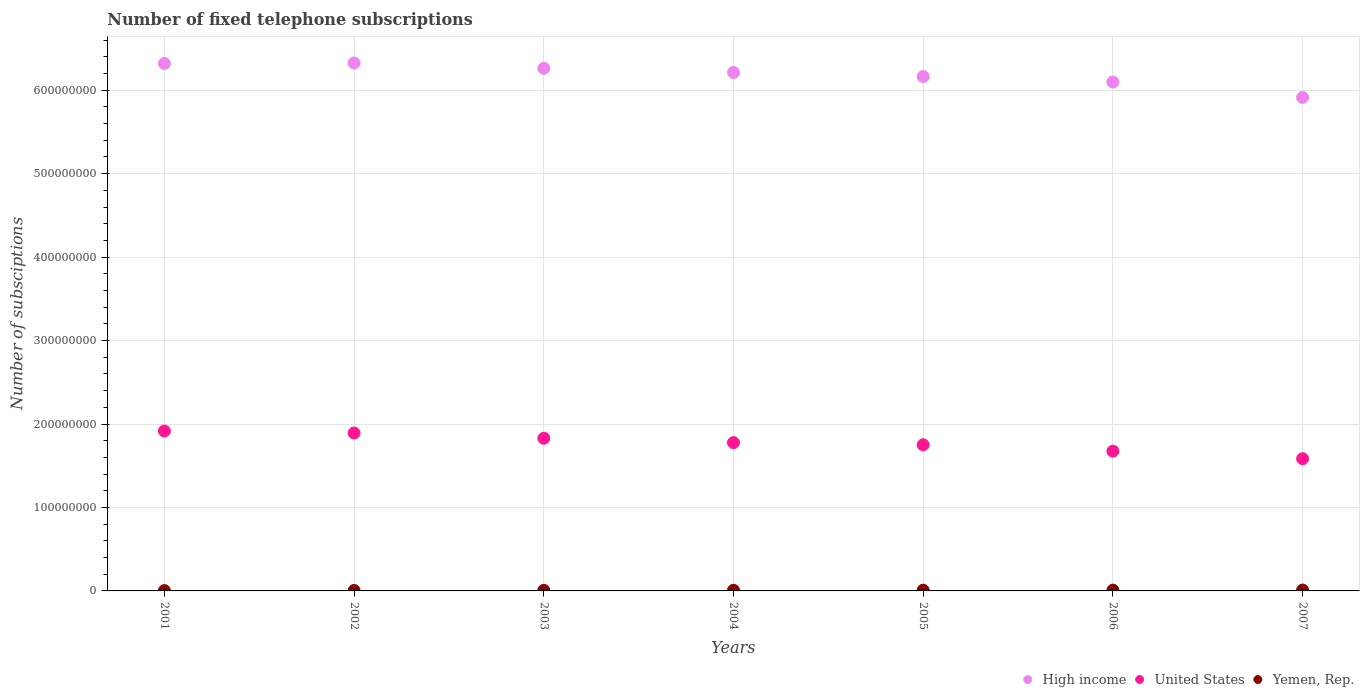How many different coloured dotlines are there?
Keep it short and to the point. 3. Is the number of dotlines equal to the number of legend labels?
Make the answer very short. Yes. What is the number of fixed telephone subscriptions in United States in 2006?
Provide a succinct answer. 1.67e+08. Across all years, what is the maximum number of fixed telephone subscriptions in United States?
Make the answer very short. 1.92e+08. Across all years, what is the minimum number of fixed telephone subscriptions in United States?
Offer a terse response. 1.58e+08. In which year was the number of fixed telephone subscriptions in High income minimum?
Provide a succinct answer. 2007. What is the total number of fixed telephone subscriptions in High income in the graph?
Keep it short and to the point. 4.33e+09. What is the difference between the number of fixed telephone subscriptions in United States in 2004 and that in 2007?
Your answer should be compact. 1.93e+07. What is the difference between the number of fixed telephone subscriptions in High income in 2006 and the number of fixed telephone subscriptions in United States in 2003?
Offer a very short reply. 4.27e+08. What is the average number of fixed telephone subscriptions in High income per year?
Your response must be concise. 6.19e+08. In the year 2004, what is the difference between the number of fixed telephone subscriptions in Yemen, Rep. and number of fixed telephone subscriptions in High income?
Your answer should be compact. -6.20e+08. What is the ratio of the number of fixed telephone subscriptions in Yemen, Rep. in 2005 to that in 2006?
Keep it short and to the point. 0.93. Is the number of fixed telephone subscriptions in Yemen, Rep. in 2002 less than that in 2003?
Give a very brief answer. Yes. What is the difference between the highest and the second highest number of fixed telephone subscriptions in United States?
Your answer should be very brief. 2.32e+06. What is the difference between the highest and the lowest number of fixed telephone subscriptions in High income?
Provide a succinct answer. 4.13e+07. In how many years, is the number of fixed telephone subscriptions in High income greater than the average number of fixed telephone subscriptions in High income taken over all years?
Make the answer very short. 4. Is the number of fixed telephone subscriptions in Yemen, Rep. strictly greater than the number of fixed telephone subscriptions in High income over the years?
Your answer should be compact. No. How many dotlines are there?
Provide a succinct answer. 3. How many years are there in the graph?
Give a very brief answer. 7. What is the difference between two consecutive major ticks on the Y-axis?
Ensure brevity in your answer.  1.00e+08. Does the graph contain grids?
Your response must be concise. Yes. How many legend labels are there?
Give a very brief answer. 3. What is the title of the graph?
Offer a terse response. Number of fixed telephone subscriptions. What is the label or title of the X-axis?
Your answer should be very brief. Years. What is the label or title of the Y-axis?
Your answer should be compact. Number of subsciptions. What is the Number of subsciptions of High income in 2001?
Offer a terse response. 6.32e+08. What is the Number of subsciptions of United States in 2001?
Provide a short and direct response. 1.92e+08. What is the Number of subsciptions of Yemen, Rep. in 2001?
Provide a short and direct response. 4.22e+05. What is the Number of subsciptions of High income in 2002?
Provide a succinct answer. 6.33e+08. What is the Number of subsciptions of United States in 2002?
Make the answer very short. 1.89e+08. What is the Number of subsciptions of Yemen, Rep. in 2002?
Give a very brief answer. 5.42e+05. What is the Number of subsciptions of High income in 2003?
Ensure brevity in your answer.  6.26e+08. What is the Number of subsciptions of United States in 2003?
Your answer should be compact. 1.83e+08. What is the Number of subsciptions of Yemen, Rep. in 2003?
Provide a short and direct response. 6.94e+05. What is the Number of subsciptions of High income in 2004?
Your response must be concise. 6.21e+08. What is the Number of subsciptions in United States in 2004?
Offer a terse response. 1.78e+08. What is the Number of subsciptions in Yemen, Rep. in 2004?
Your answer should be compact. 7.98e+05. What is the Number of subsciptions of High income in 2005?
Your answer should be very brief. 6.16e+08. What is the Number of subsciptions in United States in 2005?
Offer a terse response. 1.75e+08. What is the Number of subsciptions of Yemen, Rep. in 2005?
Your response must be concise. 9.01e+05. What is the Number of subsciptions in High income in 2006?
Ensure brevity in your answer.  6.10e+08. What is the Number of subsciptions in United States in 2006?
Offer a very short reply. 1.67e+08. What is the Number of subsciptions in Yemen, Rep. in 2006?
Your answer should be compact. 9.68e+05. What is the Number of subsciptions of High income in 2007?
Give a very brief answer. 5.91e+08. What is the Number of subsciptions in United States in 2007?
Offer a terse response. 1.58e+08. What is the Number of subsciptions in Yemen, Rep. in 2007?
Provide a succinct answer. 1.02e+06. Across all years, what is the maximum Number of subsciptions of High income?
Give a very brief answer. 6.33e+08. Across all years, what is the maximum Number of subsciptions in United States?
Your answer should be compact. 1.92e+08. Across all years, what is the maximum Number of subsciptions in Yemen, Rep.?
Your response must be concise. 1.02e+06. Across all years, what is the minimum Number of subsciptions in High income?
Make the answer very short. 5.91e+08. Across all years, what is the minimum Number of subsciptions of United States?
Offer a terse response. 1.58e+08. Across all years, what is the minimum Number of subsciptions of Yemen, Rep.?
Provide a short and direct response. 4.22e+05. What is the total Number of subsciptions of High income in the graph?
Your answer should be very brief. 4.33e+09. What is the total Number of subsciptions of United States in the graph?
Your answer should be compact. 1.24e+09. What is the total Number of subsciptions in Yemen, Rep. in the graph?
Make the answer very short. 5.35e+06. What is the difference between the Number of subsciptions of High income in 2001 and that in 2002?
Keep it short and to the point. -6.04e+05. What is the difference between the Number of subsciptions in United States in 2001 and that in 2002?
Your answer should be compact. 2.32e+06. What is the difference between the Number of subsciptions in Yemen, Rep. in 2001 and that in 2002?
Your answer should be compact. -1.20e+05. What is the difference between the Number of subsciptions in High income in 2001 and that in 2003?
Offer a very short reply. 5.84e+06. What is the difference between the Number of subsciptions of United States in 2001 and that in 2003?
Ensure brevity in your answer.  8.64e+06. What is the difference between the Number of subsciptions in Yemen, Rep. in 2001 and that in 2003?
Provide a succinct answer. -2.72e+05. What is the difference between the Number of subsciptions of High income in 2001 and that in 2004?
Make the answer very short. 1.08e+07. What is the difference between the Number of subsciptions of United States in 2001 and that in 2004?
Provide a succinct answer. 1.39e+07. What is the difference between the Number of subsciptions of Yemen, Rep. in 2001 and that in 2004?
Your response must be concise. -3.76e+05. What is the difference between the Number of subsciptions of High income in 2001 and that in 2005?
Make the answer very short. 1.56e+07. What is the difference between the Number of subsciptions of United States in 2001 and that in 2005?
Your answer should be very brief. 1.64e+07. What is the difference between the Number of subsciptions of Yemen, Rep. in 2001 and that in 2005?
Provide a short and direct response. -4.79e+05. What is the difference between the Number of subsciptions of High income in 2001 and that in 2006?
Provide a succinct answer. 2.22e+07. What is the difference between the Number of subsciptions of United States in 2001 and that in 2006?
Offer a very short reply. 2.41e+07. What is the difference between the Number of subsciptions in Yemen, Rep. in 2001 and that in 2006?
Provide a short and direct response. -5.46e+05. What is the difference between the Number of subsciptions of High income in 2001 and that in 2007?
Offer a terse response. 4.07e+07. What is the difference between the Number of subsciptions in United States in 2001 and that in 2007?
Your response must be concise. 3.32e+07. What is the difference between the Number of subsciptions in Yemen, Rep. in 2001 and that in 2007?
Offer a terse response. -6.00e+05. What is the difference between the Number of subsciptions in High income in 2002 and that in 2003?
Provide a succinct answer. 6.45e+06. What is the difference between the Number of subsciptions in United States in 2002 and that in 2003?
Offer a very short reply. 6.32e+06. What is the difference between the Number of subsciptions of Yemen, Rep. in 2002 and that in 2003?
Keep it short and to the point. -1.52e+05. What is the difference between the Number of subsciptions of High income in 2002 and that in 2004?
Offer a terse response. 1.14e+07. What is the difference between the Number of subsciptions in United States in 2002 and that in 2004?
Your answer should be very brief. 1.16e+07. What is the difference between the Number of subsciptions in Yemen, Rep. in 2002 and that in 2004?
Offer a very short reply. -2.56e+05. What is the difference between the Number of subsciptions in High income in 2002 and that in 2005?
Your response must be concise. 1.63e+07. What is the difference between the Number of subsciptions in United States in 2002 and that in 2005?
Your answer should be very brief. 1.41e+07. What is the difference between the Number of subsciptions of Yemen, Rep. in 2002 and that in 2005?
Offer a terse response. -3.59e+05. What is the difference between the Number of subsciptions of High income in 2002 and that in 2006?
Make the answer very short. 2.28e+07. What is the difference between the Number of subsciptions of United States in 2002 and that in 2006?
Offer a terse response. 2.18e+07. What is the difference between the Number of subsciptions in Yemen, Rep. in 2002 and that in 2006?
Your answer should be compact. -4.26e+05. What is the difference between the Number of subsciptions in High income in 2002 and that in 2007?
Your answer should be very brief. 4.13e+07. What is the difference between the Number of subsciptions in United States in 2002 and that in 2007?
Provide a succinct answer. 3.08e+07. What is the difference between the Number of subsciptions in Yemen, Rep. in 2002 and that in 2007?
Your answer should be compact. -4.80e+05. What is the difference between the Number of subsciptions in High income in 2003 and that in 2004?
Your answer should be compact. 4.92e+06. What is the difference between the Number of subsciptions in United States in 2003 and that in 2004?
Provide a short and direct response. 5.24e+06. What is the difference between the Number of subsciptions in Yemen, Rep. in 2003 and that in 2004?
Your response must be concise. -1.04e+05. What is the difference between the Number of subsciptions of High income in 2003 and that in 2005?
Offer a terse response. 9.80e+06. What is the difference between the Number of subsciptions in United States in 2003 and that in 2005?
Provide a succinct answer. 7.77e+06. What is the difference between the Number of subsciptions of Yemen, Rep. in 2003 and that in 2005?
Provide a succinct answer. -2.08e+05. What is the difference between the Number of subsciptions in High income in 2003 and that in 2006?
Offer a terse response. 1.64e+07. What is the difference between the Number of subsciptions in United States in 2003 and that in 2006?
Give a very brief answer. 1.55e+07. What is the difference between the Number of subsciptions of Yemen, Rep. in 2003 and that in 2006?
Offer a very short reply. -2.74e+05. What is the difference between the Number of subsciptions of High income in 2003 and that in 2007?
Your answer should be compact. 3.49e+07. What is the difference between the Number of subsciptions in United States in 2003 and that in 2007?
Make the answer very short. 2.45e+07. What is the difference between the Number of subsciptions in Yemen, Rep. in 2003 and that in 2007?
Provide a succinct answer. -3.28e+05. What is the difference between the Number of subsciptions of High income in 2004 and that in 2005?
Your answer should be very brief. 4.88e+06. What is the difference between the Number of subsciptions in United States in 2004 and that in 2005?
Your response must be concise. 2.53e+06. What is the difference between the Number of subsciptions of Yemen, Rep. in 2004 and that in 2005?
Offer a very short reply. -1.03e+05. What is the difference between the Number of subsciptions in High income in 2004 and that in 2006?
Provide a short and direct response. 1.14e+07. What is the difference between the Number of subsciptions of United States in 2004 and that in 2006?
Offer a very short reply. 1.02e+07. What is the difference between the Number of subsciptions in Yemen, Rep. in 2004 and that in 2006?
Offer a very short reply. -1.70e+05. What is the difference between the Number of subsciptions of High income in 2004 and that in 2007?
Ensure brevity in your answer.  2.99e+07. What is the difference between the Number of subsciptions of United States in 2004 and that in 2007?
Your response must be concise. 1.93e+07. What is the difference between the Number of subsciptions in Yemen, Rep. in 2004 and that in 2007?
Provide a short and direct response. -2.24e+05. What is the difference between the Number of subsciptions of High income in 2005 and that in 2006?
Your answer should be very brief. 6.56e+06. What is the difference between the Number of subsciptions in United States in 2005 and that in 2006?
Offer a terse response. 7.70e+06. What is the difference between the Number of subsciptions in Yemen, Rep. in 2005 and that in 2006?
Offer a very short reply. -6.69e+04. What is the difference between the Number of subsciptions in High income in 2005 and that in 2007?
Offer a very short reply. 2.50e+07. What is the difference between the Number of subsciptions in United States in 2005 and that in 2007?
Make the answer very short. 1.67e+07. What is the difference between the Number of subsciptions in Yemen, Rep. in 2005 and that in 2007?
Give a very brief answer. -1.21e+05. What is the difference between the Number of subsciptions in High income in 2006 and that in 2007?
Make the answer very short. 1.85e+07. What is the difference between the Number of subsciptions in United States in 2006 and that in 2007?
Provide a succinct answer. 9.04e+06. What is the difference between the Number of subsciptions of Yemen, Rep. in 2006 and that in 2007?
Keep it short and to the point. -5.37e+04. What is the difference between the Number of subsciptions of High income in 2001 and the Number of subsciptions of United States in 2002?
Offer a terse response. 4.43e+08. What is the difference between the Number of subsciptions of High income in 2001 and the Number of subsciptions of Yemen, Rep. in 2002?
Your answer should be compact. 6.31e+08. What is the difference between the Number of subsciptions in United States in 2001 and the Number of subsciptions in Yemen, Rep. in 2002?
Give a very brief answer. 1.91e+08. What is the difference between the Number of subsciptions in High income in 2001 and the Number of subsciptions in United States in 2003?
Give a very brief answer. 4.49e+08. What is the difference between the Number of subsciptions of High income in 2001 and the Number of subsciptions of Yemen, Rep. in 2003?
Provide a succinct answer. 6.31e+08. What is the difference between the Number of subsciptions in United States in 2001 and the Number of subsciptions in Yemen, Rep. in 2003?
Provide a succinct answer. 1.91e+08. What is the difference between the Number of subsciptions of High income in 2001 and the Number of subsciptions of United States in 2004?
Your response must be concise. 4.54e+08. What is the difference between the Number of subsciptions in High income in 2001 and the Number of subsciptions in Yemen, Rep. in 2004?
Keep it short and to the point. 6.31e+08. What is the difference between the Number of subsciptions in United States in 2001 and the Number of subsciptions in Yemen, Rep. in 2004?
Ensure brevity in your answer.  1.91e+08. What is the difference between the Number of subsciptions in High income in 2001 and the Number of subsciptions in United States in 2005?
Offer a terse response. 4.57e+08. What is the difference between the Number of subsciptions of High income in 2001 and the Number of subsciptions of Yemen, Rep. in 2005?
Your response must be concise. 6.31e+08. What is the difference between the Number of subsciptions in United States in 2001 and the Number of subsciptions in Yemen, Rep. in 2005?
Offer a terse response. 1.91e+08. What is the difference between the Number of subsciptions of High income in 2001 and the Number of subsciptions of United States in 2006?
Offer a terse response. 4.65e+08. What is the difference between the Number of subsciptions of High income in 2001 and the Number of subsciptions of Yemen, Rep. in 2006?
Keep it short and to the point. 6.31e+08. What is the difference between the Number of subsciptions in United States in 2001 and the Number of subsciptions in Yemen, Rep. in 2006?
Provide a short and direct response. 1.91e+08. What is the difference between the Number of subsciptions in High income in 2001 and the Number of subsciptions in United States in 2007?
Ensure brevity in your answer.  4.74e+08. What is the difference between the Number of subsciptions in High income in 2001 and the Number of subsciptions in Yemen, Rep. in 2007?
Make the answer very short. 6.31e+08. What is the difference between the Number of subsciptions of United States in 2001 and the Number of subsciptions of Yemen, Rep. in 2007?
Offer a very short reply. 1.91e+08. What is the difference between the Number of subsciptions in High income in 2002 and the Number of subsciptions in United States in 2003?
Offer a terse response. 4.50e+08. What is the difference between the Number of subsciptions of High income in 2002 and the Number of subsciptions of Yemen, Rep. in 2003?
Keep it short and to the point. 6.32e+08. What is the difference between the Number of subsciptions of United States in 2002 and the Number of subsciptions of Yemen, Rep. in 2003?
Your response must be concise. 1.89e+08. What is the difference between the Number of subsciptions of High income in 2002 and the Number of subsciptions of United States in 2004?
Give a very brief answer. 4.55e+08. What is the difference between the Number of subsciptions of High income in 2002 and the Number of subsciptions of Yemen, Rep. in 2004?
Your response must be concise. 6.32e+08. What is the difference between the Number of subsciptions of United States in 2002 and the Number of subsciptions of Yemen, Rep. in 2004?
Offer a very short reply. 1.88e+08. What is the difference between the Number of subsciptions in High income in 2002 and the Number of subsciptions in United States in 2005?
Make the answer very short. 4.57e+08. What is the difference between the Number of subsciptions in High income in 2002 and the Number of subsciptions in Yemen, Rep. in 2005?
Give a very brief answer. 6.32e+08. What is the difference between the Number of subsciptions of United States in 2002 and the Number of subsciptions of Yemen, Rep. in 2005?
Your response must be concise. 1.88e+08. What is the difference between the Number of subsciptions of High income in 2002 and the Number of subsciptions of United States in 2006?
Offer a terse response. 4.65e+08. What is the difference between the Number of subsciptions in High income in 2002 and the Number of subsciptions in Yemen, Rep. in 2006?
Give a very brief answer. 6.32e+08. What is the difference between the Number of subsciptions in United States in 2002 and the Number of subsciptions in Yemen, Rep. in 2006?
Your answer should be compact. 1.88e+08. What is the difference between the Number of subsciptions in High income in 2002 and the Number of subsciptions in United States in 2007?
Your answer should be very brief. 4.74e+08. What is the difference between the Number of subsciptions of High income in 2002 and the Number of subsciptions of Yemen, Rep. in 2007?
Your answer should be compact. 6.32e+08. What is the difference between the Number of subsciptions of United States in 2002 and the Number of subsciptions of Yemen, Rep. in 2007?
Your answer should be compact. 1.88e+08. What is the difference between the Number of subsciptions of High income in 2003 and the Number of subsciptions of United States in 2004?
Offer a terse response. 4.48e+08. What is the difference between the Number of subsciptions of High income in 2003 and the Number of subsciptions of Yemen, Rep. in 2004?
Your answer should be very brief. 6.25e+08. What is the difference between the Number of subsciptions in United States in 2003 and the Number of subsciptions in Yemen, Rep. in 2004?
Your response must be concise. 1.82e+08. What is the difference between the Number of subsciptions in High income in 2003 and the Number of subsciptions in United States in 2005?
Make the answer very short. 4.51e+08. What is the difference between the Number of subsciptions in High income in 2003 and the Number of subsciptions in Yemen, Rep. in 2005?
Your answer should be very brief. 6.25e+08. What is the difference between the Number of subsciptions in United States in 2003 and the Number of subsciptions in Yemen, Rep. in 2005?
Provide a succinct answer. 1.82e+08. What is the difference between the Number of subsciptions of High income in 2003 and the Number of subsciptions of United States in 2006?
Your answer should be compact. 4.59e+08. What is the difference between the Number of subsciptions of High income in 2003 and the Number of subsciptions of Yemen, Rep. in 2006?
Keep it short and to the point. 6.25e+08. What is the difference between the Number of subsciptions in United States in 2003 and the Number of subsciptions in Yemen, Rep. in 2006?
Your response must be concise. 1.82e+08. What is the difference between the Number of subsciptions in High income in 2003 and the Number of subsciptions in United States in 2007?
Provide a short and direct response. 4.68e+08. What is the difference between the Number of subsciptions of High income in 2003 and the Number of subsciptions of Yemen, Rep. in 2007?
Keep it short and to the point. 6.25e+08. What is the difference between the Number of subsciptions of United States in 2003 and the Number of subsciptions of Yemen, Rep. in 2007?
Offer a terse response. 1.82e+08. What is the difference between the Number of subsciptions of High income in 2004 and the Number of subsciptions of United States in 2005?
Your answer should be compact. 4.46e+08. What is the difference between the Number of subsciptions of High income in 2004 and the Number of subsciptions of Yemen, Rep. in 2005?
Offer a terse response. 6.20e+08. What is the difference between the Number of subsciptions in United States in 2004 and the Number of subsciptions in Yemen, Rep. in 2005?
Offer a terse response. 1.77e+08. What is the difference between the Number of subsciptions in High income in 2004 and the Number of subsciptions in United States in 2006?
Make the answer very short. 4.54e+08. What is the difference between the Number of subsciptions of High income in 2004 and the Number of subsciptions of Yemen, Rep. in 2006?
Provide a short and direct response. 6.20e+08. What is the difference between the Number of subsciptions in United States in 2004 and the Number of subsciptions in Yemen, Rep. in 2006?
Your answer should be very brief. 1.77e+08. What is the difference between the Number of subsciptions in High income in 2004 and the Number of subsciptions in United States in 2007?
Make the answer very short. 4.63e+08. What is the difference between the Number of subsciptions of High income in 2004 and the Number of subsciptions of Yemen, Rep. in 2007?
Provide a succinct answer. 6.20e+08. What is the difference between the Number of subsciptions in United States in 2004 and the Number of subsciptions in Yemen, Rep. in 2007?
Keep it short and to the point. 1.77e+08. What is the difference between the Number of subsciptions of High income in 2005 and the Number of subsciptions of United States in 2006?
Your answer should be very brief. 4.49e+08. What is the difference between the Number of subsciptions of High income in 2005 and the Number of subsciptions of Yemen, Rep. in 2006?
Make the answer very short. 6.15e+08. What is the difference between the Number of subsciptions in United States in 2005 and the Number of subsciptions in Yemen, Rep. in 2006?
Ensure brevity in your answer.  1.74e+08. What is the difference between the Number of subsciptions in High income in 2005 and the Number of subsciptions in United States in 2007?
Your answer should be compact. 4.58e+08. What is the difference between the Number of subsciptions of High income in 2005 and the Number of subsciptions of Yemen, Rep. in 2007?
Provide a short and direct response. 6.15e+08. What is the difference between the Number of subsciptions in United States in 2005 and the Number of subsciptions in Yemen, Rep. in 2007?
Provide a short and direct response. 1.74e+08. What is the difference between the Number of subsciptions in High income in 2006 and the Number of subsciptions in United States in 2007?
Provide a short and direct response. 4.51e+08. What is the difference between the Number of subsciptions in High income in 2006 and the Number of subsciptions in Yemen, Rep. in 2007?
Offer a terse response. 6.09e+08. What is the difference between the Number of subsciptions of United States in 2006 and the Number of subsciptions of Yemen, Rep. in 2007?
Offer a very short reply. 1.66e+08. What is the average Number of subsciptions in High income per year?
Your response must be concise. 6.19e+08. What is the average Number of subsciptions in United States per year?
Provide a short and direct response. 1.77e+08. What is the average Number of subsciptions in Yemen, Rep. per year?
Keep it short and to the point. 7.64e+05. In the year 2001, what is the difference between the Number of subsciptions of High income and Number of subsciptions of United States?
Provide a short and direct response. 4.40e+08. In the year 2001, what is the difference between the Number of subsciptions in High income and Number of subsciptions in Yemen, Rep.?
Give a very brief answer. 6.32e+08. In the year 2001, what is the difference between the Number of subsciptions in United States and Number of subsciptions in Yemen, Rep.?
Give a very brief answer. 1.91e+08. In the year 2002, what is the difference between the Number of subsciptions of High income and Number of subsciptions of United States?
Make the answer very short. 4.43e+08. In the year 2002, what is the difference between the Number of subsciptions in High income and Number of subsciptions in Yemen, Rep.?
Make the answer very short. 6.32e+08. In the year 2002, what is the difference between the Number of subsciptions of United States and Number of subsciptions of Yemen, Rep.?
Give a very brief answer. 1.89e+08. In the year 2003, what is the difference between the Number of subsciptions of High income and Number of subsciptions of United States?
Provide a short and direct response. 4.43e+08. In the year 2003, what is the difference between the Number of subsciptions in High income and Number of subsciptions in Yemen, Rep.?
Your response must be concise. 6.25e+08. In the year 2003, what is the difference between the Number of subsciptions in United States and Number of subsciptions in Yemen, Rep.?
Your answer should be very brief. 1.82e+08. In the year 2004, what is the difference between the Number of subsciptions of High income and Number of subsciptions of United States?
Offer a terse response. 4.44e+08. In the year 2004, what is the difference between the Number of subsciptions in High income and Number of subsciptions in Yemen, Rep.?
Keep it short and to the point. 6.20e+08. In the year 2004, what is the difference between the Number of subsciptions in United States and Number of subsciptions in Yemen, Rep.?
Your answer should be compact. 1.77e+08. In the year 2005, what is the difference between the Number of subsciptions of High income and Number of subsciptions of United States?
Provide a short and direct response. 4.41e+08. In the year 2005, what is the difference between the Number of subsciptions in High income and Number of subsciptions in Yemen, Rep.?
Offer a very short reply. 6.15e+08. In the year 2005, what is the difference between the Number of subsciptions in United States and Number of subsciptions in Yemen, Rep.?
Give a very brief answer. 1.74e+08. In the year 2006, what is the difference between the Number of subsciptions of High income and Number of subsciptions of United States?
Make the answer very short. 4.42e+08. In the year 2006, what is the difference between the Number of subsciptions of High income and Number of subsciptions of Yemen, Rep.?
Offer a very short reply. 6.09e+08. In the year 2006, what is the difference between the Number of subsciptions in United States and Number of subsciptions in Yemen, Rep.?
Offer a terse response. 1.66e+08. In the year 2007, what is the difference between the Number of subsciptions of High income and Number of subsciptions of United States?
Your answer should be very brief. 4.33e+08. In the year 2007, what is the difference between the Number of subsciptions in High income and Number of subsciptions in Yemen, Rep.?
Your response must be concise. 5.90e+08. In the year 2007, what is the difference between the Number of subsciptions of United States and Number of subsciptions of Yemen, Rep.?
Provide a succinct answer. 1.57e+08. What is the ratio of the Number of subsciptions of High income in 2001 to that in 2002?
Make the answer very short. 1. What is the ratio of the Number of subsciptions in United States in 2001 to that in 2002?
Give a very brief answer. 1.01. What is the ratio of the Number of subsciptions in Yemen, Rep. in 2001 to that in 2002?
Give a very brief answer. 0.78. What is the ratio of the Number of subsciptions in High income in 2001 to that in 2003?
Provide a succinct answer. 1.01. What is the ratio of the Number of subsciptions in United States in 2001 to that in 2003?
Ensure brevity in your answer.  1.05. What is the ratio of the Number of subsciptions in Yemen, Rep. in 2001 to that in 2003?
Offer a terse response. 0.61. What is the ratio of the Number of subsciptions in High income in 2001 to that in 2004?
Give a very brief answer. 1.02. What is the ratio of the Number of subsciptions in United States in 2001 to that in 2004?
Your answer should be very brief. 1.08. What is the ratio of the Number of subsciptions of Yemen, Rep. in 2001 to that in 2004?
Ensure brevity in your answer.  0.53. What is the ratio of the Number of subsciptions in High income in 2001 to that in 2005?
Keep it short and to the point. 1.03. What is the ratio of the Number of subsciptions of United States in 2001 to that in 2005?
Keep it short and to the point. 1.09. What is the ratio of the Number of subsciptions in Yemen, Rep. in 2001 to that in 2005?
Offer a terse response. 0.47. What is the ratio of the Number of subsciptions of High income in 2001 to that in 2006?
Give a very brief answer. 1.04. What is the ratio of the Number of subsciptions in United States in 2001 to that in 2006?
Your answer should be very brief. 1.14. What is the ratio of the Number of subsciptions of Yemen, Rep. in 2001 to that in 2006?
Offer a very short reply. 0.44. What is the ratio of the Number of subsciptions of High income in 2001 to that in 2007?
Ensure brevity in your answer.  1.07. What is the ratio of the Number of subsciptions in United States in 2001 to that in 2007?
Your response must be concise. 1.21. What is the ratio of the Number of subsciptions of Yemen, Rep. in 2001 to that in 2007?
Offer a terse response. 0.41. What is the ratio of the Number of subsciptions of High income in 2002 to that in 2003?
Your answer should be very brief. 1.01. What is the ratio of the Number of subsciptions of United States in 2002 to that in 2003?
Provide a short and direct response. 1.03. What is the ratio of the Number of subsciptions of Yemen, Rep. in 2002 to that in 2003?
Offer a very short reply. 0.78. What is the ratio of the Number of subsciptions in High income in 2002 to that in 2004?
Your answer should be very brief. 1.02. What is the ratio of the Number of subsciptions in United States in 2002 to that in 2004?
Ensure brevity in your answer.  1.07. What is the ratio of the Number of subsciptions of Yemen, Rep. in 2002 to that in 2004?
Offer a very short reply. 0.68. What is the ratio of the Number of subsciptions of High income in 2002 to that in 2005?
Ensure brevity in your answer.  1.03. What is the ratio of the Number of subsciptions in United States in 2002 to that in 2005?
Provide a short and direct response. 1.08. What is the ratio of the Number of subsciptions of Yemen, Rep. in 2002 to that in 2005?
Ensure brevity in your answer.  0.6. What is the ratio of the Number of subsciptions in High income in 2002 to that in 2006?
Ensure brevity in your answer.  1.04. What is the ratio of the Number of subsciptions in United States in 2002 to that in 2006?
Ensure brevity in your answer.  1.13. What is the ratio of the Number of subsciptions of Yemen, Rep. in 2002 to that in 2006?
Provide a short and direct response. 0.56. What is the ratio of the Number of subsciptions in High income in 2002 to that in 2007?
Your response must be concise. 1.07. What is the ratio of the Number of subsciptions in United States in 2002 to that in 2007?
Provide a short and direct response. 1.19. What is the ratio of the Number of subsciptions of Yemen, Rep. in 2002 to that in 2007?
Keep it short and to the point. 0.53. What is the ratio of the Number of subsciptions in High income in 2003 to that in 2004?
Your answer should be very brief. 1.01. What is the ratio of the Number of subsciptions in United States in 2003 to that in 2004?
Make the answer very short. 1.03. What is the ratio of the Number of subsciptions of Yemen, Rep. in 2003 to that in 2004?
Keep it short and to the point. 0.87. What is the ratio of the Number of subsciptions of High income in 2003 to that in 2005?
Give a very brief answer. 1.02. What is the ratio of the Number of subsciptions of United States in 2003 to that in 2005?
Offer a very short reply. 1.04. What is the ratio of the Number of subsciptions of Yemen, Rep. in 2003 to that in 2005?
Your answer should be very brief. 0.77. What is the ratio of the Number of subsciptions in High income in 2003 to that in 2006?
Offer a very short reply. 1.03. What is the ratio of the Number of subsciptions in United States in 2003 to that in 2006?
Offer a very short reply. 1.09. What is the ratio of the Number of subsciptions of Yemen, Rep. in 2003 to that in 2006?
Offer a terse response. 0.72. What is the ratio of the Number of subsciptions in High income in 2003 to that in 2007?
Ensure brevity in your answer.  1.06. What is the ratio of the Number of subsciptions in United States in 2003 to that in 2007?
Provide a succinct answer. 1.15. What is the ratio of the Number of subsciptions in Yemen, Rep. in 2003 to that in 2007?
Keep it short and to the point. 0.68. What is the ratio of the Number of subsciptions in High income in 2004 to that in 2005?
Make the answer very short. 1.01. What is the ratio of the Number of subsciptions in United States in 2004 to that in 2005?
Keep it short and to the point. 1.01. What is the ratio of the Number of subsciptions in Yemen, Rep. in 2004 to that in 2005?
Give a very brief answer. 0.89. What is the ratio of the Number of subsciptions in High income in 2004 to that in 2006?
Make the answer very short. 1.02. What is the ratio of the Number of subsciptions in United States in 2004 to that in 2006?
Your response must be concise. 1.06. What is the ratio of the Number of subsciptions of Yemen, Rep. in 2004 to that in 2006?
Ensure brevity in your answer.  0.82. What is the ratio of the Number of subsciptions of High income in 2004 to that in 2007?
Offer a terse response. 1.05. What is the ratio of the Number of subsciptions of United States in 2004 to that in 2007?
Keep it short and to the point. 1.12. What is the ratio of the Number of subsciptions in Yemen, Rep. in 2004 to that in 2007?
Make the answer very short. 0.78. What is the ratio of the Number of subsciptions in High income in 2005 to that in 2006?
Give a very brief answer. 1.01. What is the ratio of the Number of subsciptions of United States in 2005 to that in 2006?
Keep it short and to the point. 1.05. What is the ratio of the Number of subsciptions of Yemen, Rep. in 2005 to that in 2006?
Your response must be concise. 0.93. What is the ratio of the Number of subsciptions in High income in 2005 to that in 2007?
Offer a terse response. 1.04. What is the ratio of the Number of subsciptions in United States in 2005 to that in 2007?
Offer a very short reply. 1.11. What is the ratio of the Number of subsciptions in Yemen, Rep. in 2005 to that in 2007?
Ensure brevity in your answer.  0.88. What is the ratio of the Number of subsciptions in High income in 2006 to that in 2007?
Give a very brief answer. 1.03. What is the ratio of the Number of subsciptions of United States in 2006 to that in 2007?
Your answer should be very brief. 1.06. What is the ratio of the Number of subsciptions in Yemen, Rep. in 2006 to that in 2007?
Make the answer very short. 0.95. What is the difference between the highest and the second highest Number of subsciptions in High income?
Keep it short and to the point. 6.04e+05. What is the difference between the highest and the second highest Number of subsciptions of United States?
Offer a very short reply. 2.32e+06. What is the difference between the highest and the second highest Number of subsciptions of Yemen, Rep.?
Ensure brevity in your answer.  5.37e+04. What is the difference between the highest and the lowest Number of subsciptions in High income?
Make the answer very short. 4.13e+07. What is the difference between the highest and the lowest Number of subsciptions in United States?
Provide a succinct answer. 3.32e+07. What is the difference between the highest and the lowest Number of subsciptions in Yemen, Rep.?
Your response must be concise. 6.00e+05. 